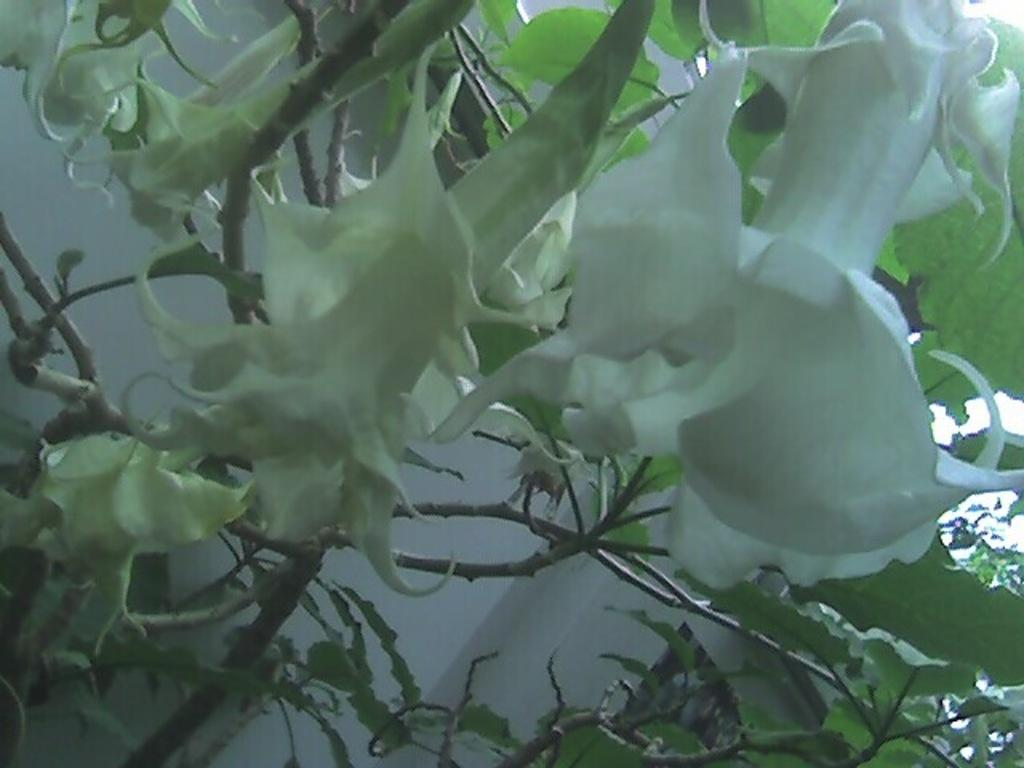What type of plants are present in the image? There are plants with flowers in the image. What other features can be observed on the plants? The plants have leaves. What can be seen in the background of the image? There is a white wall and the sky visible in the background of the image. What type of quill does the grandmother use to write in the image? There is no grandmother or quill present in the image. 